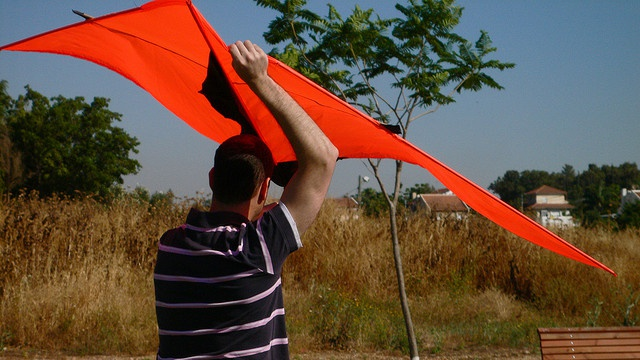Describe the objects in this image and their specific colors. I can see people in gray, black, maroon, and tan tones, kite in gray, red, black, and brown tones, kite in gray, red, black, and brown tones, and bench in gray, brown, and maroon tones in this image. 